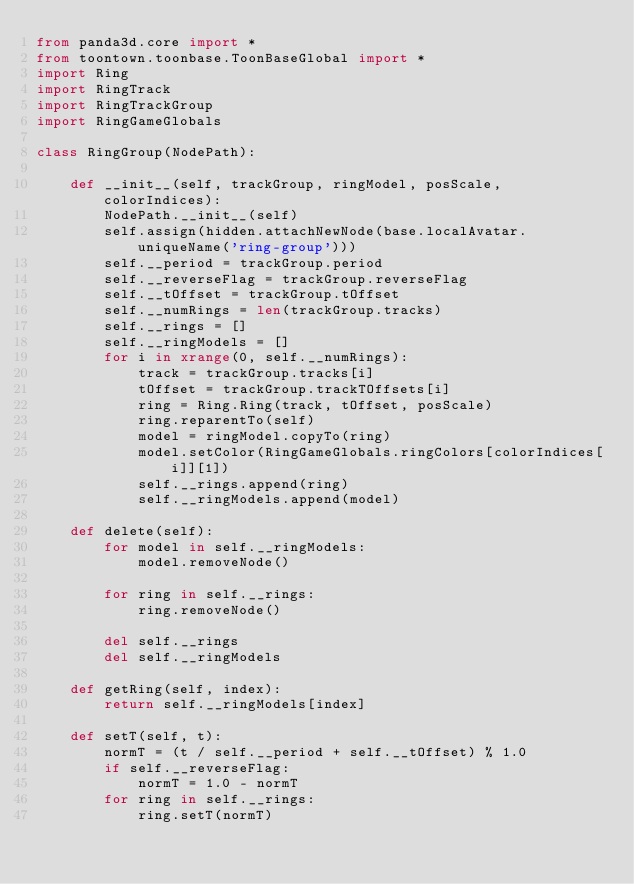Convert code to text. <code><loc_0><loc_0><loc_500><loc_500><_Python_>from panda3d.core import *
from toontown.toonbase.ToonBaseGlobal import *
import Ring
import RingTrack
import RingTrackGroup
import RingGameGlobals

class RingGroup(NodePath):

    def __init__(self, trackGroup, ringModel, posScale, colorIndices):
        NodePath.__init__(self)
        self.assign(hidden.attachNewNode(base.localAvatar.uniqueName('ring-group')))
        self.__period = trackGroup.period
        self.__reverseFlag = trackGroup.reverseFlag
        self.__tOffset = trackGroup.tOffset
        self.__numRings = len(trackGroup.tracks)
        self.__rings = []
        self.__ringModels = []
        for i in xrange(0, self.__numRings):
            track = trackGroup.tracks[i]
            tOffset = trackGroup.trackTOffsets[i]
            ring = Ring.Ring(track, tOffset, posScale)
            ring.reparentTo(self)
            model = ringModel.copyTo(ring)
            model.setColor(RingGameGlobals.ringColors[colorIndices[i]][1])
            self.__rings.append(ring)
            self.__ringModels.append(model)

    def delete(self):
        for model in self.__ringModels:
            model.removeNode()

        for ring in self.__rings:
            ring.removeNode()

        del self.__rings
        del self.__ringModels

    def getRing(self, index):
        return self.__ringModels[index]

    def setT(self, t):
        normT = (t / self.__period + self.__tOffset) % 1.0
        if self.__reverseFlag:
            normT = 1.0 - normT
        for ring in self.__rings:
            ring.setT(normT)
</code> 